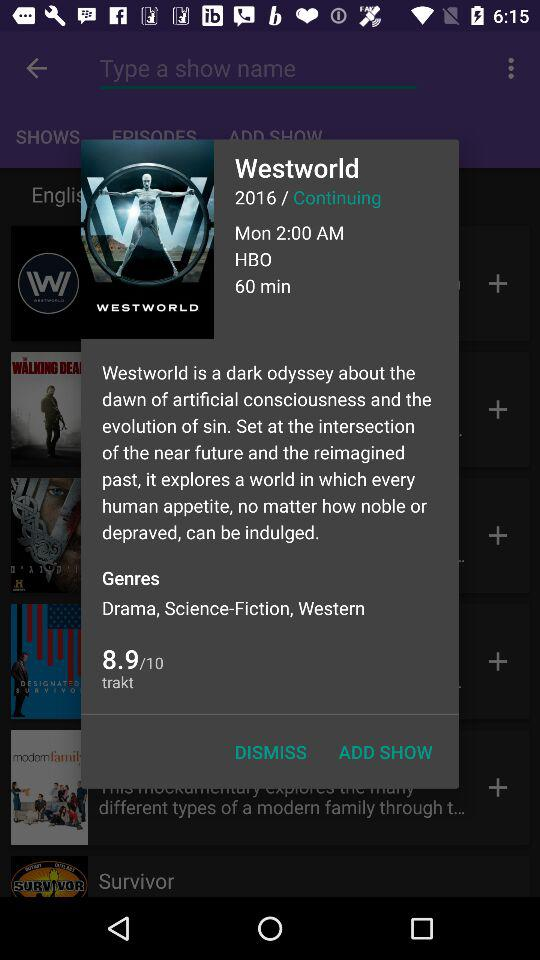How many episodes does "Westworld" have?
When the provided information is insufficient, respond with <no answer>. <no answer> 